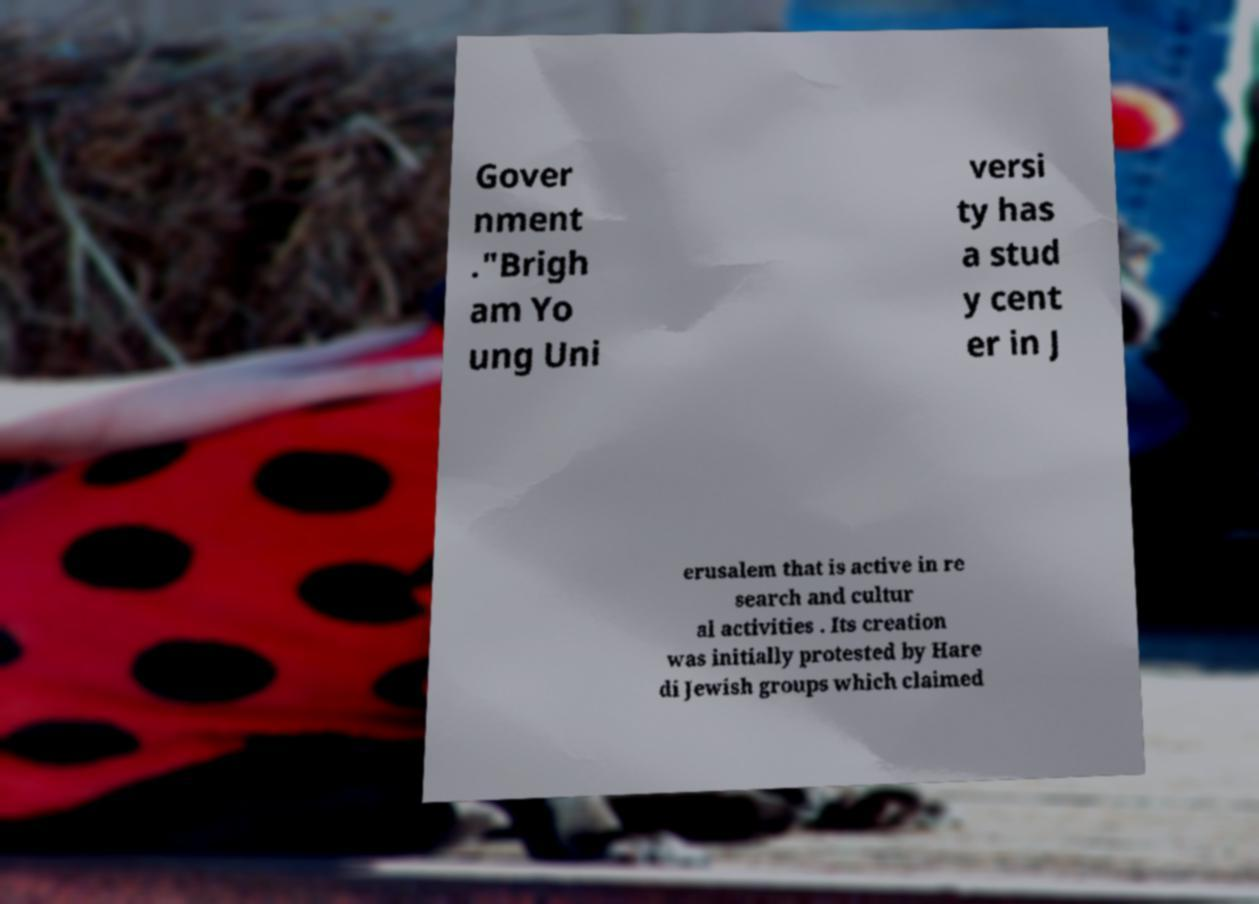Please read and relay the text visible in this image. What does it say? Gover nment ."Brigh am Yo ung Uni versi ty has a stud y cent er in J erusalem that is active in re search and cultur al activities . Its creation was initially protested by Hare di Jewish groups which claimed 